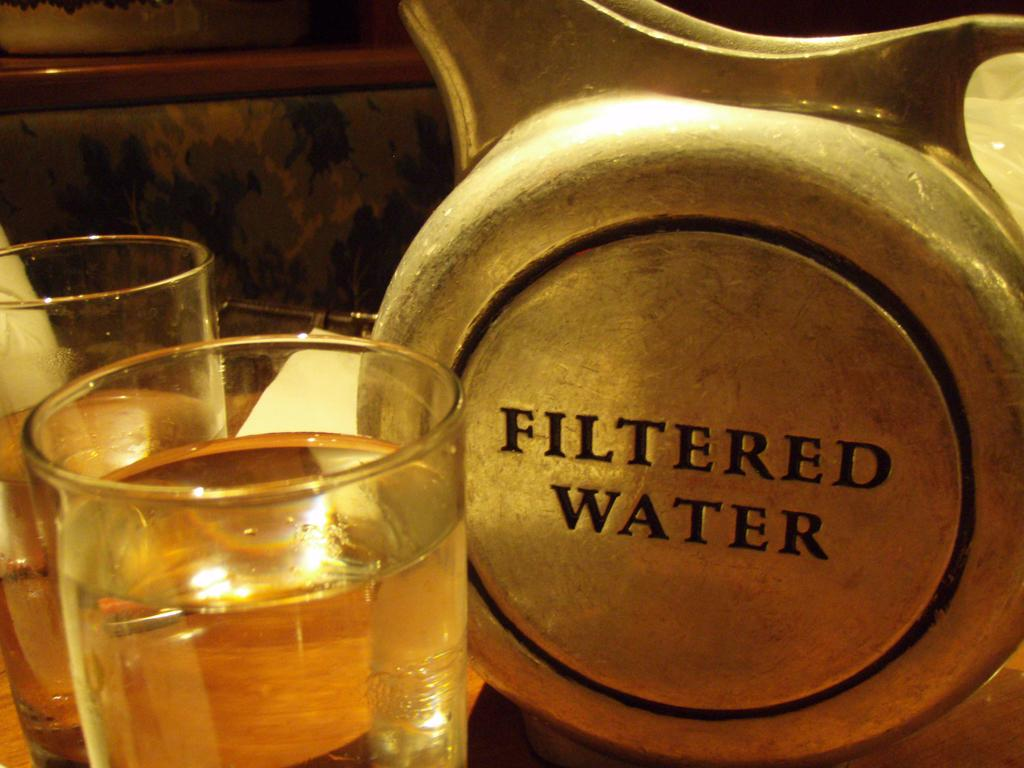<image>
Describe the image concisely. glasses of liquid next to a sign saying filtered water 